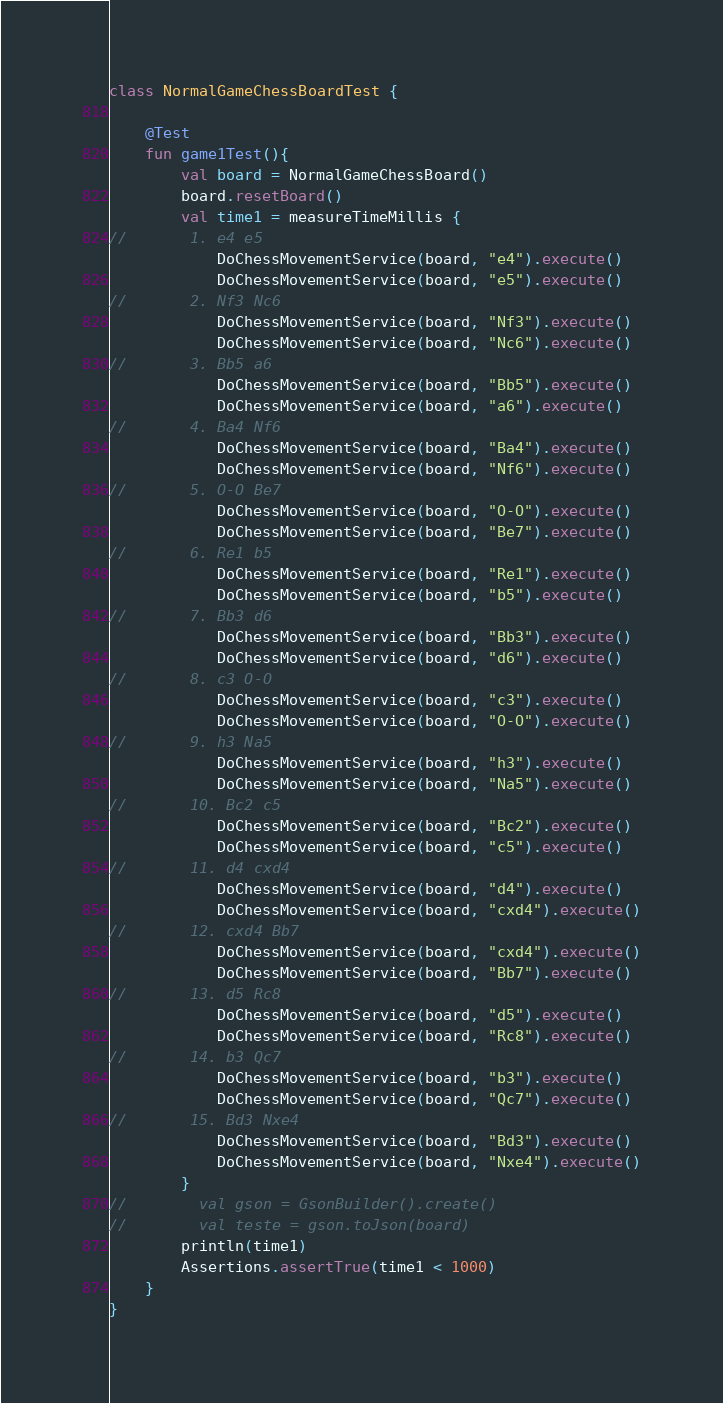<code> <loc_0><loc_0><loc_500><loc_500><_Kotlin_>
class NormalGameChessBoardTest {

    @Test
    fun game1Test(){
        val board = NormalGameChessBoard()
        board.resetBoard()
        val time1 = measureTimeMillis {
//       1. e4 e5
            DoChessMovementService(board, "e4").execute()
            DoChessMovementService(board, "e5").execute()
//       2. Nf3 Nc6
            DoChessMovementService(board, "Nf3").execute()
            DoChessMovementService(board, "Nc6").execute()
//       3. Bb5 a6
            DoChessMovementService(board, "Bb5").execute()
            DoChessMovementService(board, "a6").execute()
//       4. Ba4 Nf6
            DoChessMovementService(board, "Ba4").execute()
            DoChessMovementService(board, "Nf6").execute()
//       5. O-O Be7
            DoChessMovementService(board, "O-O").execute()
            DoChessMovementService(board, "Be7").execute()
//       6. Re1 b5
            DoChessMovementService(board, "Re1").execute()
            DoChessMovementService(board, "b5").execute()
//       7. Bb3 d6
            DoChessMovementService(board, "Bb3").execute()
            DoChessMovementService(board, "d6").execute()
//       8. c3 O-O
            DoChessMovementService(board, "c3").execute()
            DoChessMovementService(board, "O-O").execute()
//       9. h3 Na5
            DoChessMovementService(board, "h3").execute()
            DoChessMovementService(board, "Na5").execute()
//       10. Bc2 c5
            DoChessMovementService(board, "Bc2").execute()
            DoChessMovementService(board, "c5").execute()
//       11. d4 cxd4
            DoChessMovementService(board, "d4").execute()
            DoChessMovementService(board, "cxd4").execute()
//       12. cxd4 Bb7
            DoChessMovementService(board, "cxd4").execute()
            DoChessMovementService(board, "Bb7").execute()
//       13. d5 Rc8
            DoChessMovementService(board, "d5").execute()
            DoChessMovementService(board, "Rc8").execute()
//       14. b3 Qc7
            DoChessMovementService(board, "b3").execute()
            DoChessMovementService(board, "Qc7").execute()
//       15. Bd3 Nxe4
            DoChessMovementService(board, "Bd3").execute()
            DoChessMovementService(board, "Nxe4").execute()
        }
//        val gson = GsonBuilder().create()
//        val teste = gson.toJson(board)
        println(time1)
        Assertions.assertTrue(time1 < 1000)
    }
}</code> 